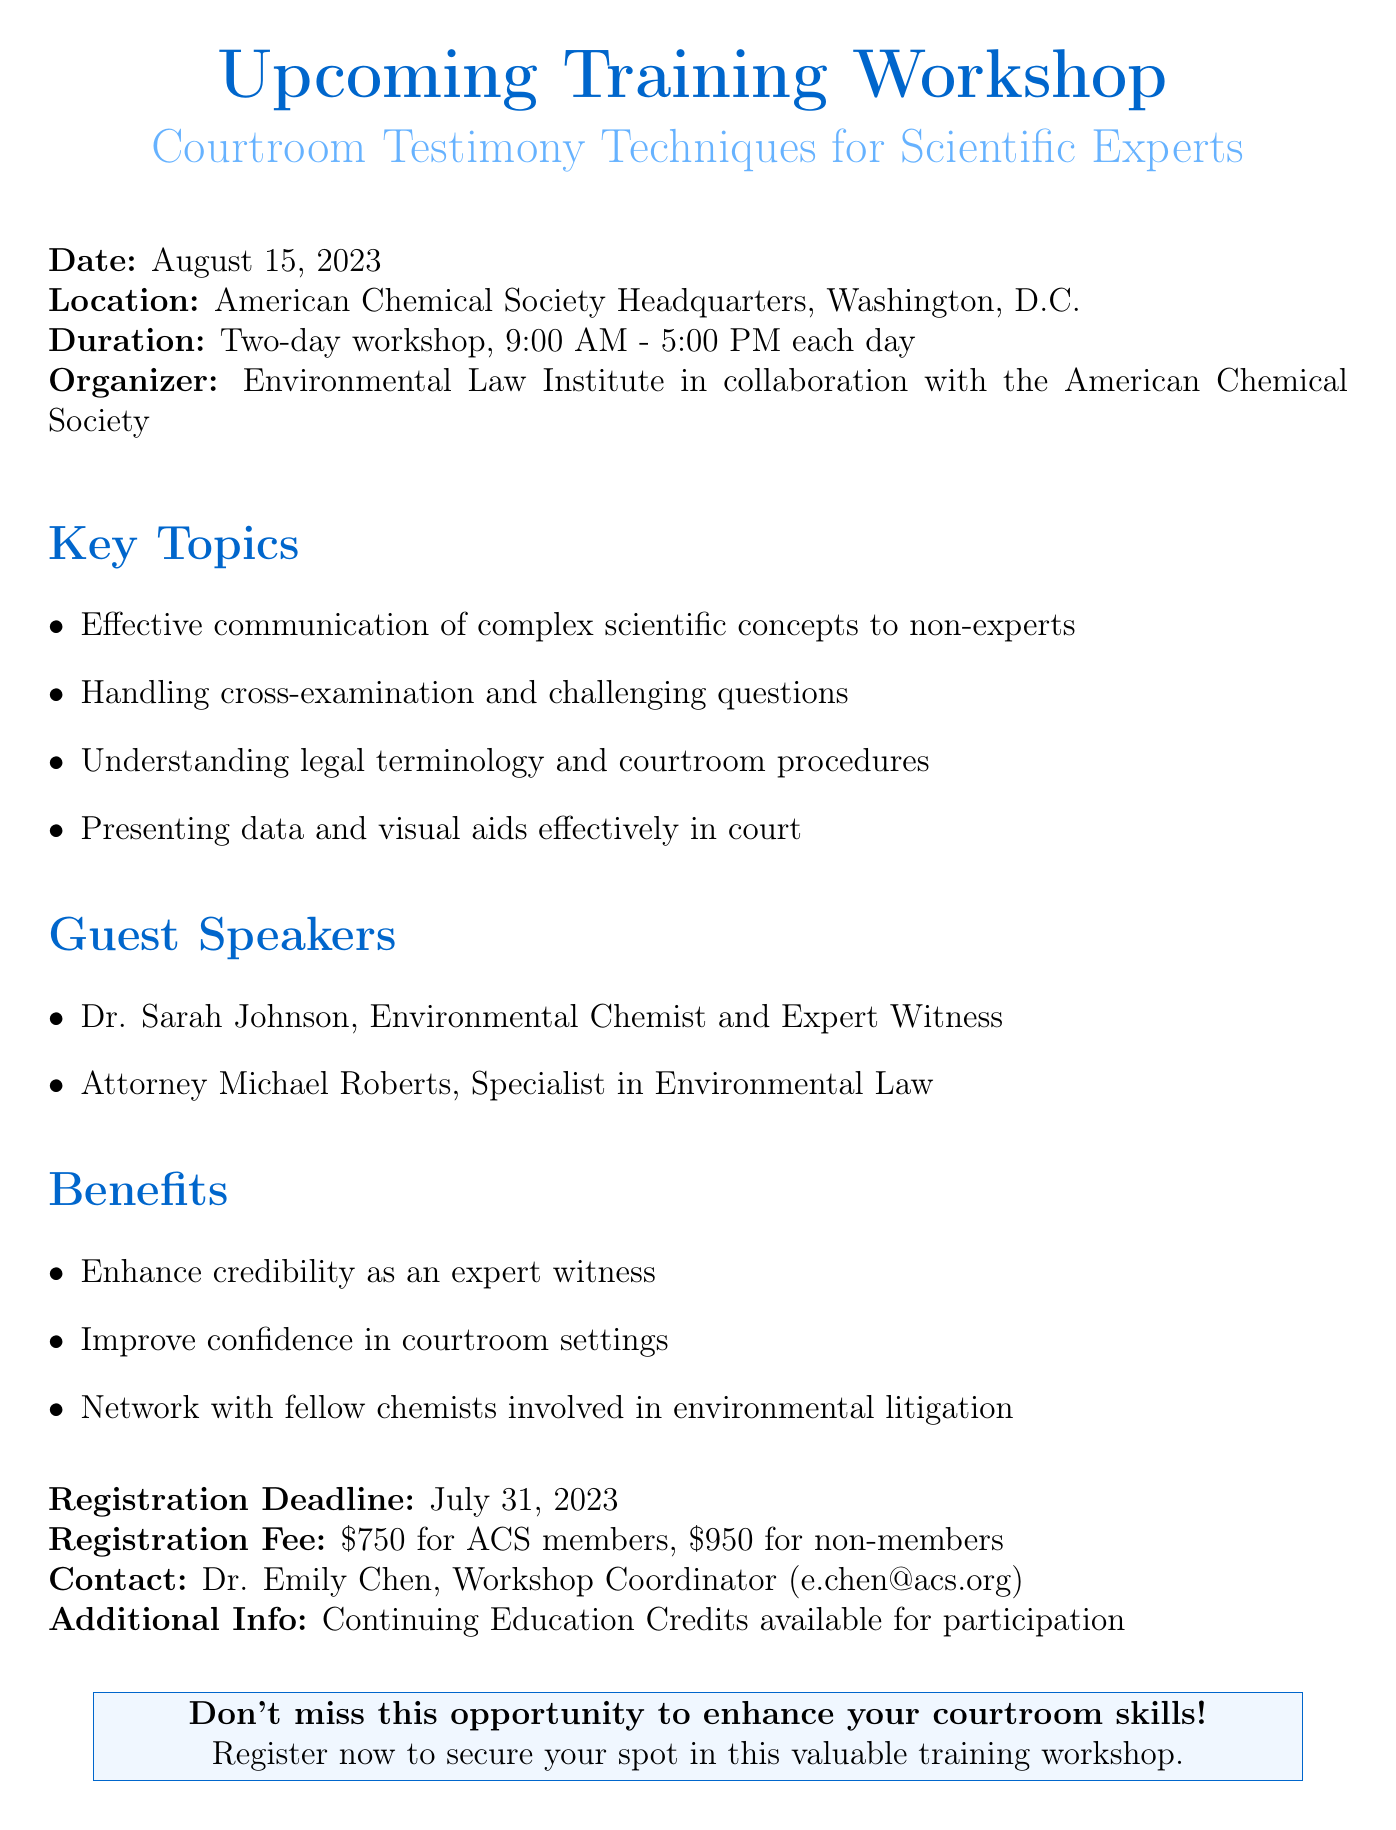What is the date of the workshop? The date of the workshop is explicitly stated in the document as August 15, 2023.
Answer: August 15, 2023 Where is the workshop located? The location of the workshop is specified in the document as the American Chemical Society Headquarters, Washington, D.C.
Answer: American Chemical Society Headquarters, Washington, D.C What are the registration fees for non-members? The registration fees are outlined in the document as $950 for non-members.
Answer: $950 Who is the workshop coordinator? The document provides the contact information for Dr. Emily Chen as the workshop coordinator.
Answer: Dr. Emily Chen What is one of the key topics covered in the workshop? The document lists several key topics, such as effective communication of complex scientific concepts to non-experts.
Answer: Effective communication of complex scientific concepts to non-experts What benefits does the workshop offer? The document states the benefits include enhancing credibility as an expert witness and improving confidence in courtroom settings.
Answer: Enhance credibility as an expert witness How long is the duration of the workshop? The duration of the workshop is mentioned as a two-day workshop, running from 9:00 AM to 5:00 PM each day.
Answer: Two-day workshop, 9:00 AM - 5:00 PM each day When is the registration deadline? The document clearly specifies the registration deadline as July 31, 2023.
Answer: July 31, 2023 